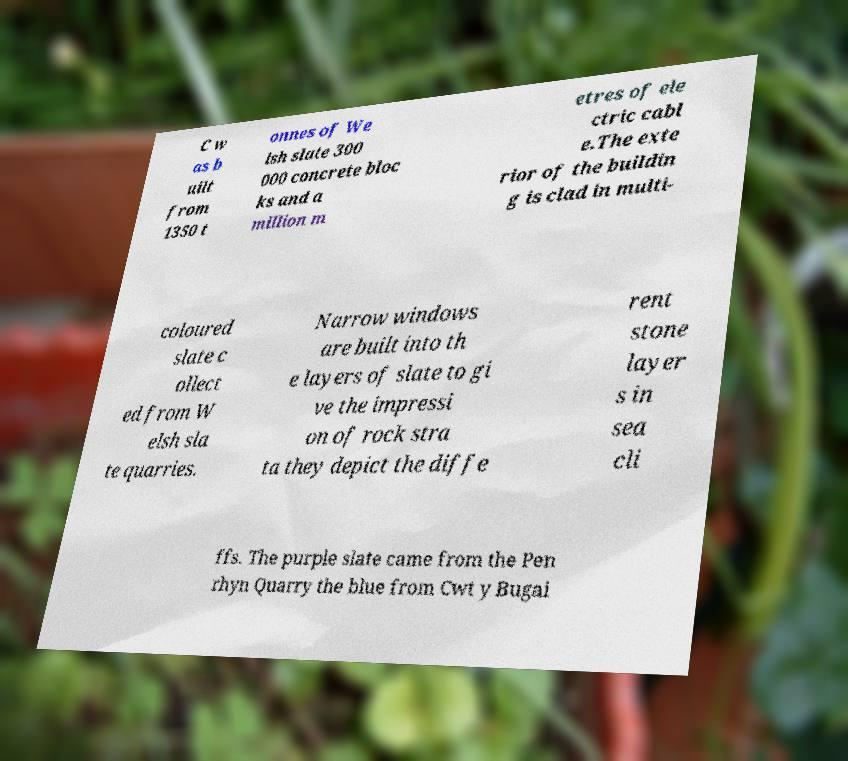Could you extract and type out the text from this image? C w as b uilt from 1350 t onnes of We lsh slate 300 000 concrete bloc ks and a million m etres of ele ctric cabl e.The exte rior of the buildin g is clad in multi- coloured slate c ollect ed from W elsh sla te quarries. Narrow windows are built into th e layers of slate to gi ve the impressi on of rock stra ta they depict the diffe rent stone layer s in sea cli ffs. The purple slate came from the Pen rhyn Quarry the blue from Cwt y Bugai 